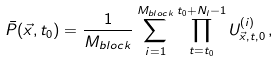<formula> <loc_0><loc_0><loc_500><loc_500>\bar { P } ( \vec { x } , t _ { 0 } ) = \frac { 1 } { M _ { b l o c k } } \sum _ { i = 1 } ^ { M _ { b l o c k } } \prod _ { t = t _ { 0 } } ^ { t _ { 0 } + N _ { l } - 1 } U _ { \vec { x } , t , 0 } ^ { ( i ) } \, ,</formula> 